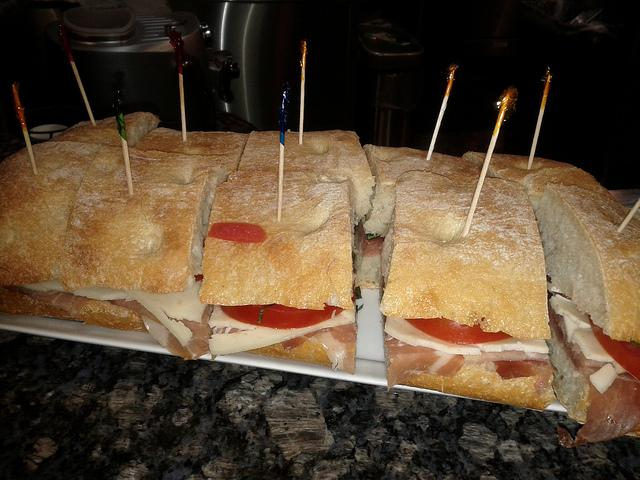What is being used to keep the sandwiches from falling apart? Please explain your reasoning. toothpicks. The small wooden sticks in the sandwiches are used to keep them from falling apart. 